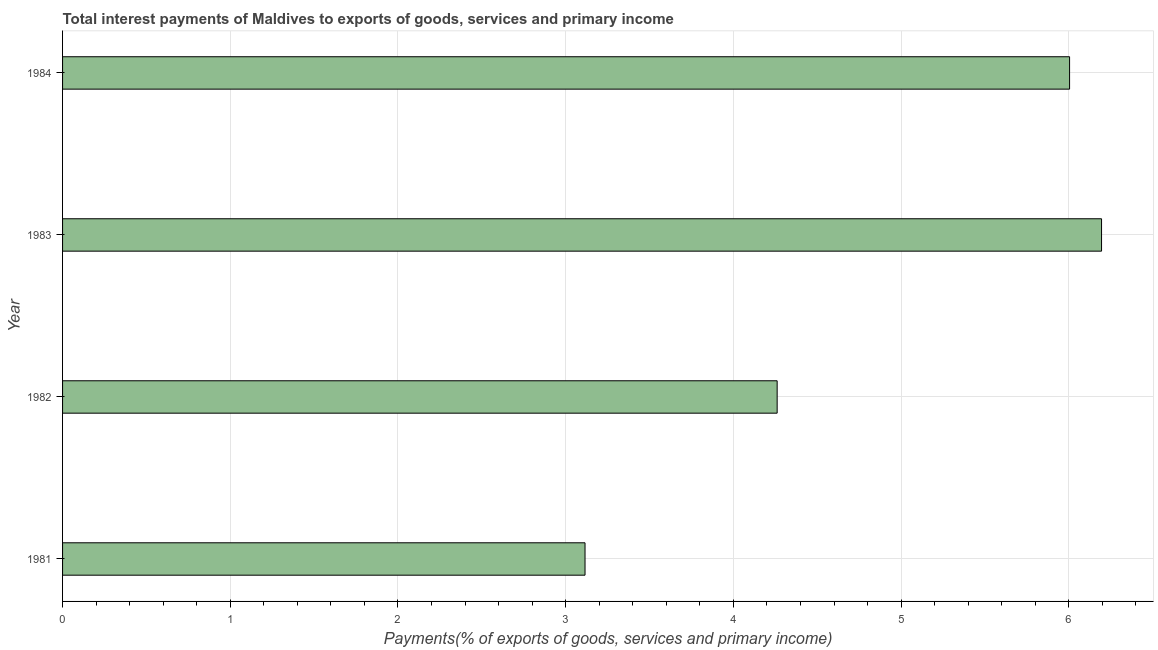Does the graph contain any zero values?
Keep it short and to the point. No. What is the title of the graph?
Make the answer very short. Total interest payments of Maldives to exports of goods, services and primary income. What is the label or title of the X-axis?
Offer a terse response. Payments(% of exports of goods, services and primary income). What is the total interest payments on external debt in 1983?
Offer a very short reply. 6.2. Across all years, what is the maximum total interest payments on external debt?
Offer a terse response. 6.2. Across all years, what is the minimum total interest payments on external debt?
Offer a very short reply. 3.12. In which year was the total interest payments on external debt maximum?
Offer a terse response. 1983. In which year was the total interest payments on external debt minimum?
Ensure brevity in your answer.  1981. What is the sum of the total interest payments on external debt?
Give a very brief answer. 19.58. What is the difference between the total interest payments on external debt in 1981 and 1984?
Your answer should be very brief. -2.89. What is the average total interest payments on external debt per year?
Your response must be concise. 4.89. What is the median total interest payments on external debt?
Ensure brevity in your answer.  5.13. What is the ratio of the total interest payments on external debt in 1982 to that in 1984?
Offer a very short reply. 0.71. Is the total interest payments on external debt in 1983 less than that in 1984?
Your response must be concise. No. What is the difference between the highest and the second highest total interest payments on external debt?
Your response must be concise. 0.19. Is the sum of the total interest payments on external debt in 1981 and 1982 greater than the maximum total interest payments on external debt across all years?
Provide a succinct answer. Yes. What is the difference between the highest and the lowest total interest payments on external debt?
Keep it short and to the point. 3.08. In how many years, is the total interest payments on external debt greater than the average total interest payments on external debt taken over all years?
Ensure brevity in your answer.  2. Are all the bars in the graph horizontal?
Your answer should be compact. Yes. What is the difference between two consecutive major ticks on the X-axis?
Keep it short and to the point. 1. What is the Payments(% of exports of goods, services and primary income) of 1981?
Make the answer very short. 3.12. What is the Payments(% of exports of goods, services and primary income) in 1982?
Your response must be concise. 4.26. What is the Payments(% of exports of goods, services and primary income) in 1983?
Provide a succinct answer. 6.2. What is the Payments(% of exports of goods, services and primary income) in 1984?
Offer a terse response. 6. What is the difference between the Payments(% of exports of goods, services and primary income) in 1981 and 1982?
Provide a succinct answer. -1.15. What is the difference between the Payments(% of exports of goods, services and primary income) in 1981 and 1983?
Your answer should be very brief. -3.08. What is the difference between the Payments(% of exports of goods, services and primary income) in 1981 and 1984?
Offer a terse response. -2.89. What is the difference between the Payments(% of exports of goods, services and primary income) in 1982 and 1983?
Offer a very short reply. -1.93. What is the difference between the Payments(% of exports of goods, services and primary income) in 1982 and 1984?
Provide a succinct answer. -1.74. What is the difference between the Payments(% of exports of goods, services and primary income) in 1983 and 1984?
Offer a terse response. 0.19. What is the ratio of the Payments(% of exports of goods, services and primary income) in 1981 to that in 1982?
Ensure brevity in your answer.  0.73. What is the ratio of the Payments(% of exports of goods, services and primary income) in 1981 to that in 1983?
Give a very brief answer. 0.5. What is the ratio of the Payments(% of exports of goods, services and primary income) in 1981 to that in 1984?
Keep it short and to the point. 0.52. What is the ratio of the Payments(% of exports of goods, services and primary income) in 1982 to that in 1983?
Your response must be concise. 0.69. What is the ratio of the Payments(% of exports of goods, services and primary income) in 1982 to that in 1984?
Keep it short and to the point. 0.71. What is the ratio of the Payments(% of exports of goods, services and primary income) in 1983 to that in 1984?
Give a very brief answer. 1.03. 